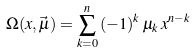Convert formula to latex. <formula><loc_0><loc_0><loc_500><loc_500>\Omega ( x , \vec { \mu } ) = \sum _ { k = 0 } ^ { n } \, ( - 1 ) ^ { k } \, \mu _ { k } \, x ^ { n - k } \,</formula> 